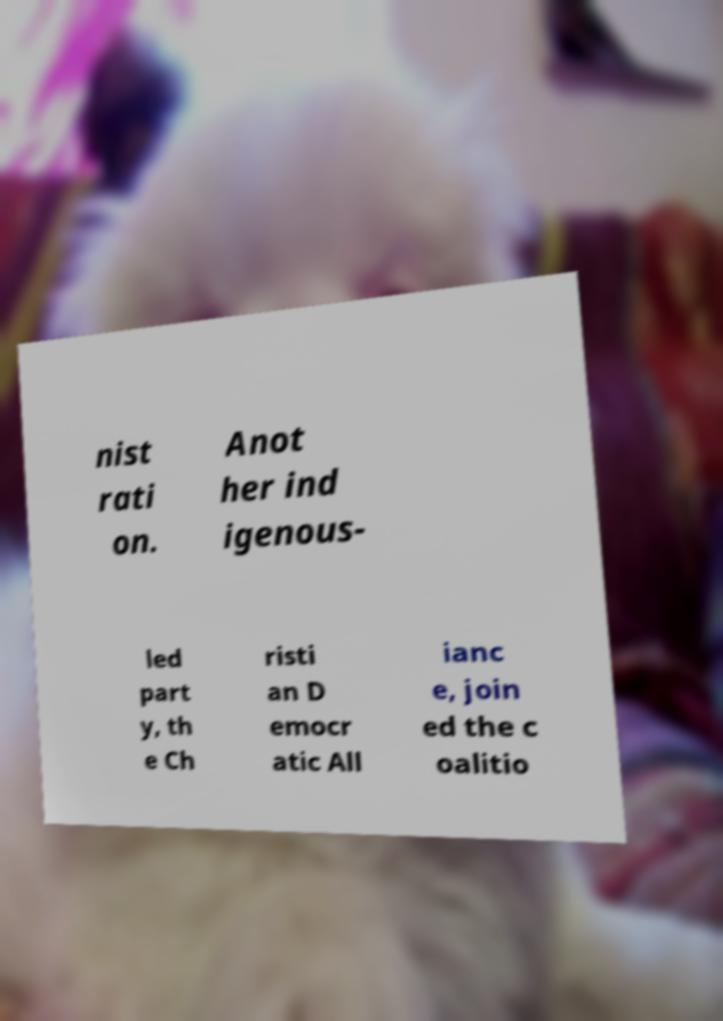Could you extract and type out the text from this image? nist rati on. Anot her ind igenous- led part y, th e Ch risti an D emocr atic All ianc e, join ed the c oalitio 